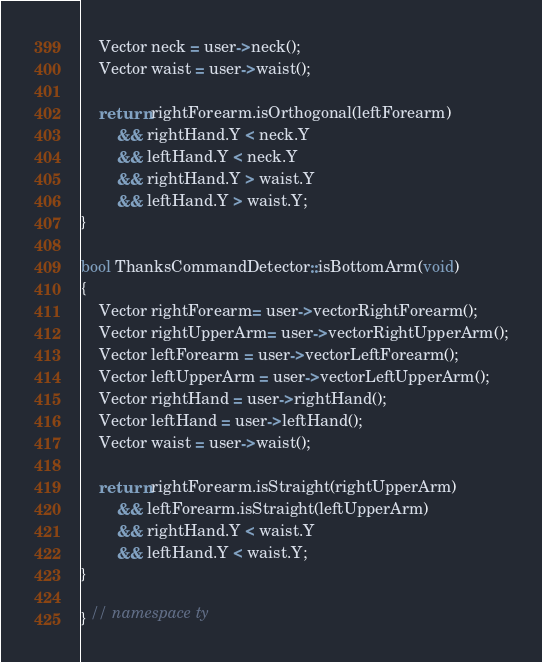<code> <loc_0><loc_0><loc_500><loc_500><_C++_>    Vector neck = user->neck();
    Vector waist = user->waist();

    return rightForearm.isOrthogonal(leftForearm)
        && rightHand.Y < neck.Y
        && leftHand.Y < neck.Y
        && rightHand.Y > waist.Y
        && leftHand.Y > waist.Y;    
}

bool ThanksCommandDetector::isBottomArm(void)
{
    Vector rightForearm= user->vectorRightForearm();
    Vector rightUpperArm= user->vectorRightUpperArm();
    Vector leftForearm = user->vectorLeftForearm();
    Vector leftUpperArm = user->vectorLeftUpperArm();
    Vector rightHand = user->rightHand();
    Vector leftHand = user->leftHand();
    Vector waist = user->waist();

    return rightForearm.isStraight(rightUpperArm)
        && leftForearm.isStraight(leftUpperArm)
        && rightHand.Y < waist.Y
        && leftHand.Y < waist.Y;
}

} // namespace ty
</code> 